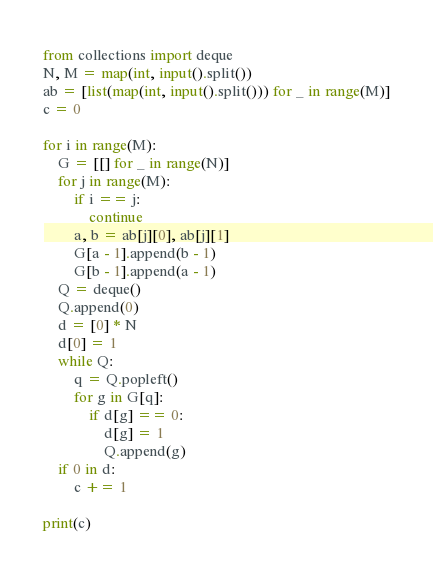<code> <loc_0><loc_0><loc_500><loc_500><_Python_>from collections import deque
N, M = map(int, input().split())
ab = [list(map(int, input().split())) for _ in range(M)]
c = 0

for i in range(M):
    G = [[] for _ in range(N)]
    for j in range(M):
        if i == j:
            continue
        a, b = ab[j][0], ab[j][1]
        G[a - 1].append(b - 1)
        G[b - 1].append(a - 1)
    Q = deque()
    Q.append(0)
    d = [0] * N
    d[0] = 1
    while Q:
        q = Q.popleft()
        for g in G[q]:
            if d[g] == 0:
                d[g] = 1
                Q.append(g)
    if 0 in d:
        c += 1

print(c)</code> 